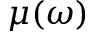Convert formula to latex. <formula><loc_0><loc_0><loc_500><loc_500>\mu ( \omega )</formula> 